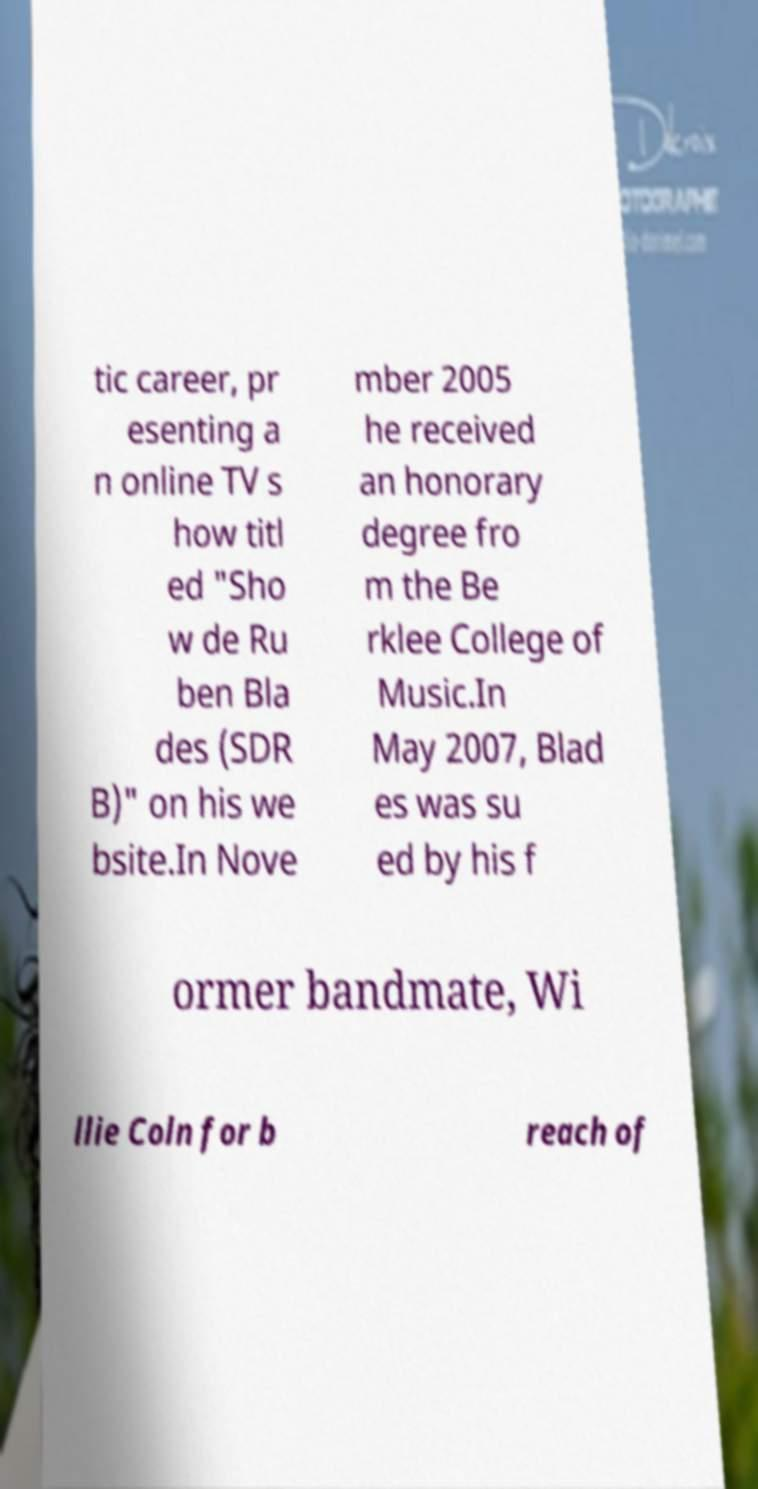Could you extract and type out the text from this image? tic career, pr esenting a n online TV s how titl ed "Sho w de Ru ben Bla des (SDR B)" on his we bsite.In Nove mber 2005 he received an honorary degree fro m the Be rklee College of Music.In May 2007, Blad es was su ed by his f ormer bandmate, Wi llie Coln for b reach of 